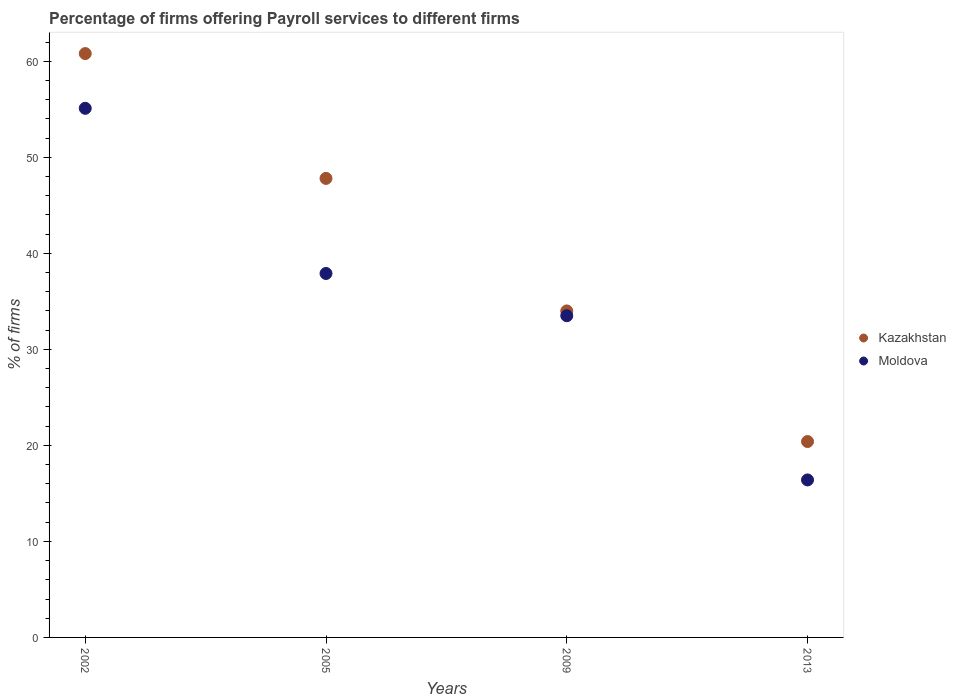How many different coloured dotlines are there?
Offer a very short reply. 2. Across all years, what is the maximum percentage of firms offering payroll services in Kazakhstan?
Offer a very short reply. 60.8. Across all years, what is the minimum percentage of firms offering payroll services in Kazakhstan?
Ensure brevity in your answer.  20.4. In which year was the percentage of firms offering payroll services in Kazakhstan maximum?
Offer a terse response. 2002. In which year was the percentage of firms offering payroll services in Moldova minimum?
Offer a very short reply. 2013. What is the total percentage of firms offering payroll services in Moldova in the graph?
Make the answer very short. 142.9. What is the difference between the percentage of firms offering payroll services in Kazakhstan in 2009 and that in 2013?
Keep it short and to the point. 13.6. What is the difference between the percentage of firms offering payroll services in Kazakhstan in 2002 and the percentage of firms offering payroll services in Moldova in 2009?
Give a very brief answer. 27.3. What is the average percentage of firms offering payroll services in Moldova per year?
Keep it short and to the point. 35.73. In the year 2005, what is the difference between the percentage of firms offering payroll services in Moldova and percentage of firms offering payroll services in Kazakhstan?
Keep it short and to the point. -9.9. What is the ratio of the percentage of firms offering payroll services in Kazakhstan in 2002 to that in 2005?
Ensure brevity in your answer.  1.27. Is the percentage of firms offering payroll services in Moldova in 2005 less than that in 2013?
Your answer should be very brief. No. What is the difference between the highest and the lowest percentage of firms offering payroll services in Moldova?
Offer a very short reply. 38.7. Does the percentage of firms offering payroll services in Moldova monotonically increase over the years?
Your answer should be very brief. No. Is the percentage of firms offering payroll services in Kazakhstan strictly greater than the percentage of firms offering payroll services in Moldova over the years?
Keep it short and to the point. Yes. Is the percentage of firms offering payroll services in Kazakhstan strictly less than the percentage of firms offering payroll services in Moldova over the years?
Your response must be concise. No. Does the graph contain grids?
Provide a short and direct response. No. How many legend labels are there?
Your answer should be compact. 2. What is the title of the graph?
Offer a terse response. Percentage of firms offering Payroll services to different firms. Does "Papua New Guinea" appear as one of the legend labels in the graph?
Offer a terse response. No. What is the label or title of the X-axis?
Your response must be concise. Years. What is the label or title of the Y-axis?
Your response must be concise. % of firms. What is the % of firms in Kazakhstan in 2002?
Your response must be concise. 60.8. What is the % of firms in Moldova in 2002?
Provide a succinct answer. 55.1. What is the % of firms of Kazakhstan in 2005?
Keep it short and to the point. 47.8. What is the % of firms in Moldova in 2005?
Provide a succinct answer. 37.9. What is the % of firms in Moldova in 2009?
Your answer should be compact. 33.5. What is the % of firms of Kazakhstan in 2013?
Your answer should be very brief. 20.4. Across all years, what is the maximum % of firms in Kazakhstan?
Offer a very short reply. 60.8. Across all years, what is the maximum % of firms of Moldova?
Offer a terse response. 55.1. Across all years, what is the minimum % of firms of Kazakhstan?
Your answer should be very brief. 20.4. What is the total % of firms in Kazakhstan in the graph?
Ensure brevity in your answer.  163. What is the total % of firms of Moldova in the graph?
Your response must be concise. 142.9. What is the difference between the % of firms of Kazakhstan in 2002 and that in 2005?
Your response must be concise. 13. What is the difference between the % of firms in Kazakhstan in 2002 and that in 2009?
Give a very brief answer. 26.8. What is the difference between the % of firms of Moldova in 2002 and that in 2009?
Offer a terse response. 21.6. What is the difference between the % of firms of Kazakhstan in 2002 and that in 2013?
Make the answer very short. 40.4. What is the difference between the % of firms in Moldova in 2002 and that in 2013?
Keep it short and to the point. 38.7. What is the difference between the % of firms in Moldova in 2005 and that in 2009?
Give a very brief answer. 4.4. What is the difference between the % of firms in Kazakhstan in 2005 and that in 2013?
Give a very brief answer. 27.4. What is the difference between the % of firms of Moldova in 2005 and that in 2013?
Provide a succinct answer. 21.5. What is the difference between the % of firms in Kazakhstan in 2009 and that in 2013?
Give a very brief answer. 13.6. What is the difference between the % of firms of Kazakhstan in 2002 and the % of firms of Moldova in 2005?
Make the answer very short. 22.9. What is the difference between the % of firms in Kazakhstan in 2002 and the % of firms in Moldova in 2009?
Make the answer very short. 27.3. What is the difference between the % of firms in Kazakhstan in 2002 and the % of firms in Moldova in 2013?
Keep it short and to the point. 44.4. What is the difference between the % of firms in Kazakhstan in 2005 and the % of firms in Moldova in 2009?
Offer a very short reply. 14.3. What is the difference between the % of firms in Kazakhstan in 2005 and the % of firms in Moldova in 2013?
Your response must be concise. 31.4. What is the average % of firms in Kazakhstan per year?
Provide a succinct answer. 40.75. What is the average % of firms in Moldova per year?
Your answer should be compact. 35.73. In the year 2002, what is the difference between the % of firms of Kazakhstan and % of firms of Moldova?
Offer a terse response. 5.7. What is the ratio of the % of firms of Kazakhstan in 2002 to that in 2005?
Ensure brevity in your answer.  1.27. What is the ratio of the % of firms in Moldova in 2002 to that in 2005?
Give a very brief answer. 1.45. What is the ratio of the % of firms of Kazakhstan in 2002 to that in 2009?
Your answer should be compact. 1.79. What is the ratio of the % of firms of Moldova in 2002 to that in 2009?
Offer a very short reply. 1.64. What is the ratio of the % of firms of Kazakhstan in 2002 to that in 2013?
Ensure brevity in your answer.  2.98. What is the ratio of the % of firms in Moldova in 2002 to that in 2013?
Provide a short and direct response. 3.36. What is the ratio of the % of firms of Kazakhstan in 2005 to that in 2009?
Your answer should be compact. 1.41. What is the ratio of the % of firms in Moldova in 2005 to that in 2009?
Give a very brief answer. 1.13. What is the ratio of the % of firms in Kazakhstan in 2005 to that in 2013?
Your response must be concise. 2.34. What is the ratio of the % of firms of Moldova in 2005 to that in 2013?
Your answer should be compact. 2.31. What is the ratio of the % of firms of Moldova in 2009 to that in 2013?
Offer a terse response. 2.04. What is the difference between the highest and the second highest % of firms of Moldova?
Keep it short and to the point. 17.2. What is the difference between the highest and the lowest % of firms of Kazakhstan?
Your response must be concise. 40.4. What is the difference between the highest and the lowest % of firms in Moldova?
Ensure brevity in your answer.  38.7. 